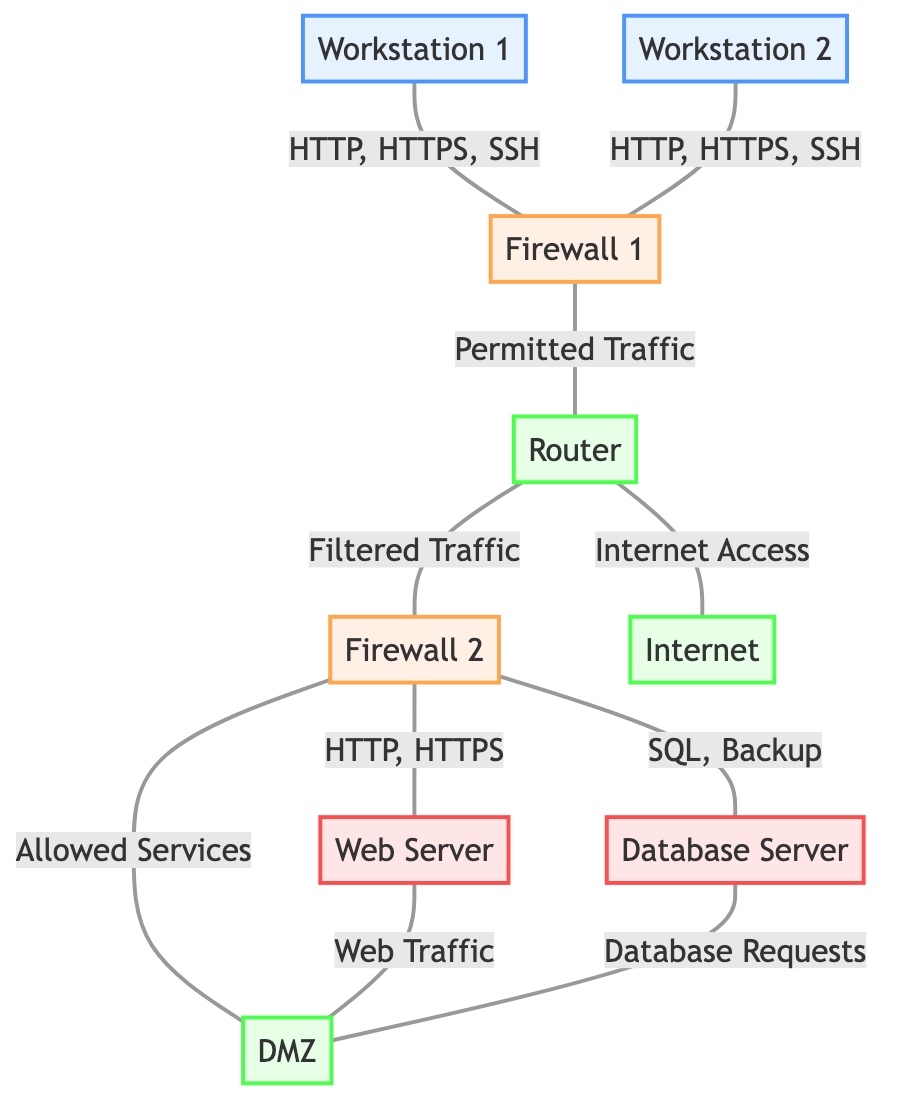What's the total number of nodes in the diagram? The diagram includes the following nodes: Workstation 1, Workstation 2, Database Server, Web Server, Firewall 1, Firewall 2, DMZ, Router, and Internet, totaling 9 nodes.
Answer: 9 Which node connects directly to Firewall 2? Analyzing the edges, Firewall 2 connects directly to three nodes: Database Server, Web Server, and DMZ. Thus, the direct connections are those three.
Answer: Database Server, Web Server, DMZ What type of traffic is allowed from Firewall 1 to the Router? The edge between Firewall 1 and Router describes the traffic as "Permitted Traffic". Thus, the type of traffic allowed on that connection is listed in the description.
Answer: Permitted Traffic How many edges are originating from the Router? Counting the edges that start from the Router, they include connections to Firewall 2 and the Internet. Therefore, there are two edges originating from the Router.
Answer: 2 What is the relationship between the Web Server and the DMZ? The diagram shows a direct connection from the Web Server to the DMZ, describing the traffic as "Web Traffic." This relationship indicates that the Web Server sends web traffic to the DMZ.
Answer: Web Traffic What protocols are allowed from Workstation 1 to Firewall 1? The traffic description on the edge from Workstation 1 to Firewall 1 includes HTTP, HTTPS, and SSH. These protocols define the types of communication permitted on that connection.
Answer: HTTP, HTTPS, SSH Which node has the most connections in the diagram? Analyzing all connections, Firewall 2 has the most edges connecting it to three nodes: Database Server, Web Server, and DMZ. Thus, it has the highest number of connections.
Answer: Firewall 2 What services does Firewall 2 allow to DMZ? The diagram specifies that Firewall 2 allows "Allowed Services" to the DMZ. This description indicates the services that can flow from Firewall 2 to the DMZ.
Answer: Allowed Services How does the Internet connect to the Router? The edge from Router to Internet is described as "Internet Access," indicating that the Router serves as the gateway to the Internet for the network.
Answer: Internet Access 